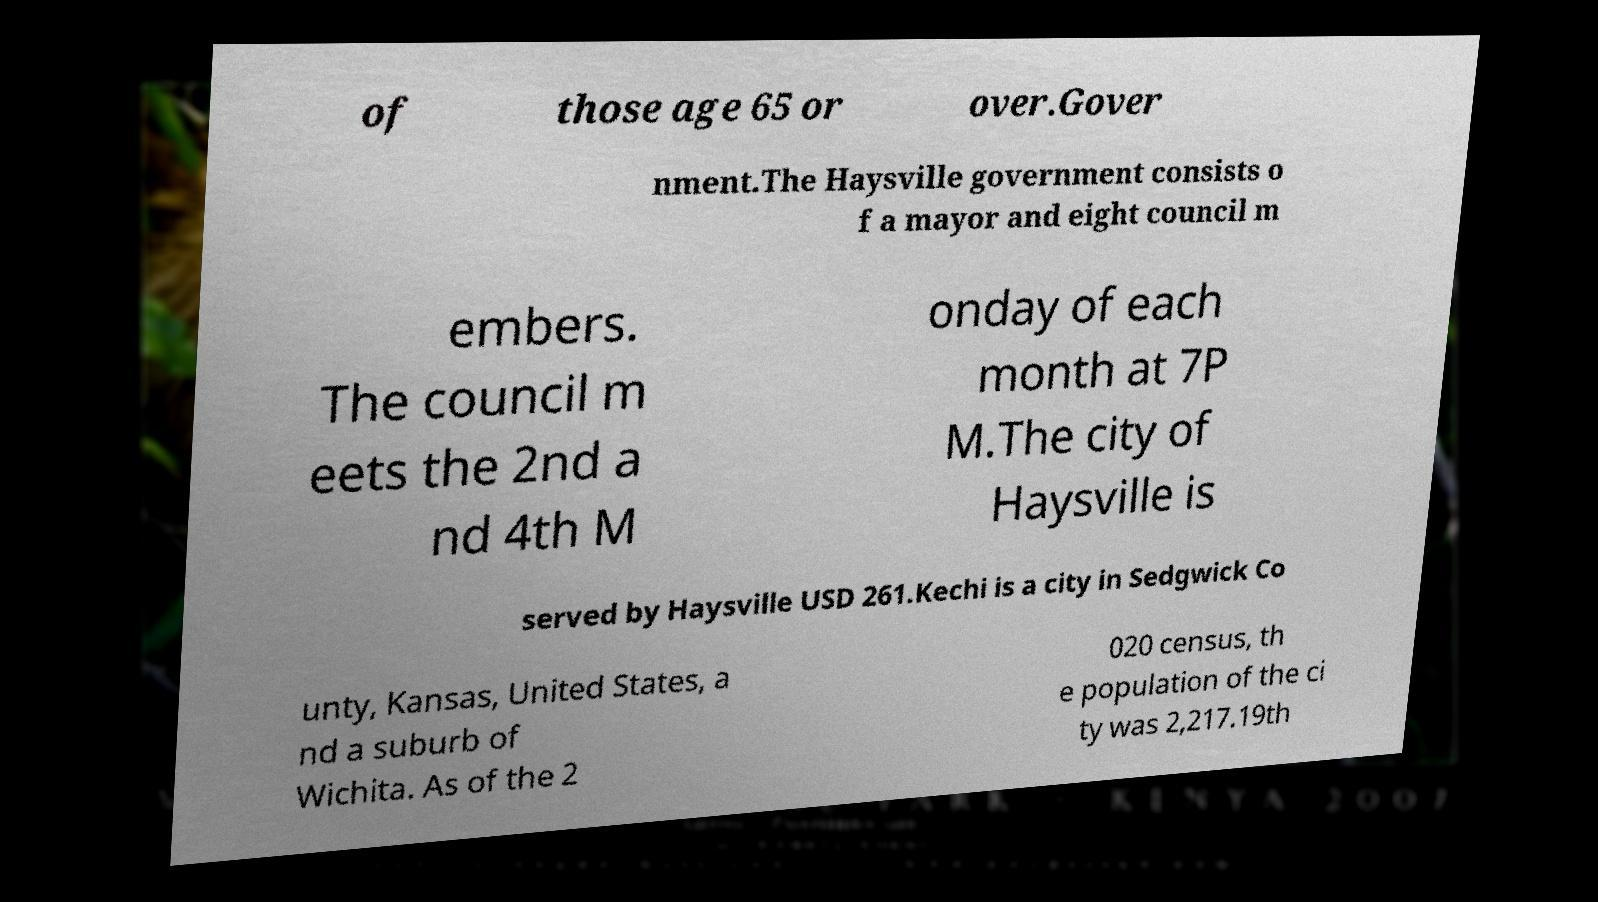Could you assist in decoding the text presented in this image and type it out clearly? of those age 65 or over.Gover nment.The Haysville government consists o f a mayor and eight council m embers. The council m eets the 2nd a nd 4th M onday of each month at 7P M.The city of Haysville is served by Haysville USD 261.Kechi is a city in Sedgwick Co unty, Kansas, United States, a nd a suburb of Wichita. As of the 2 020 census, th e population of the ci ty was 2,217.19th 